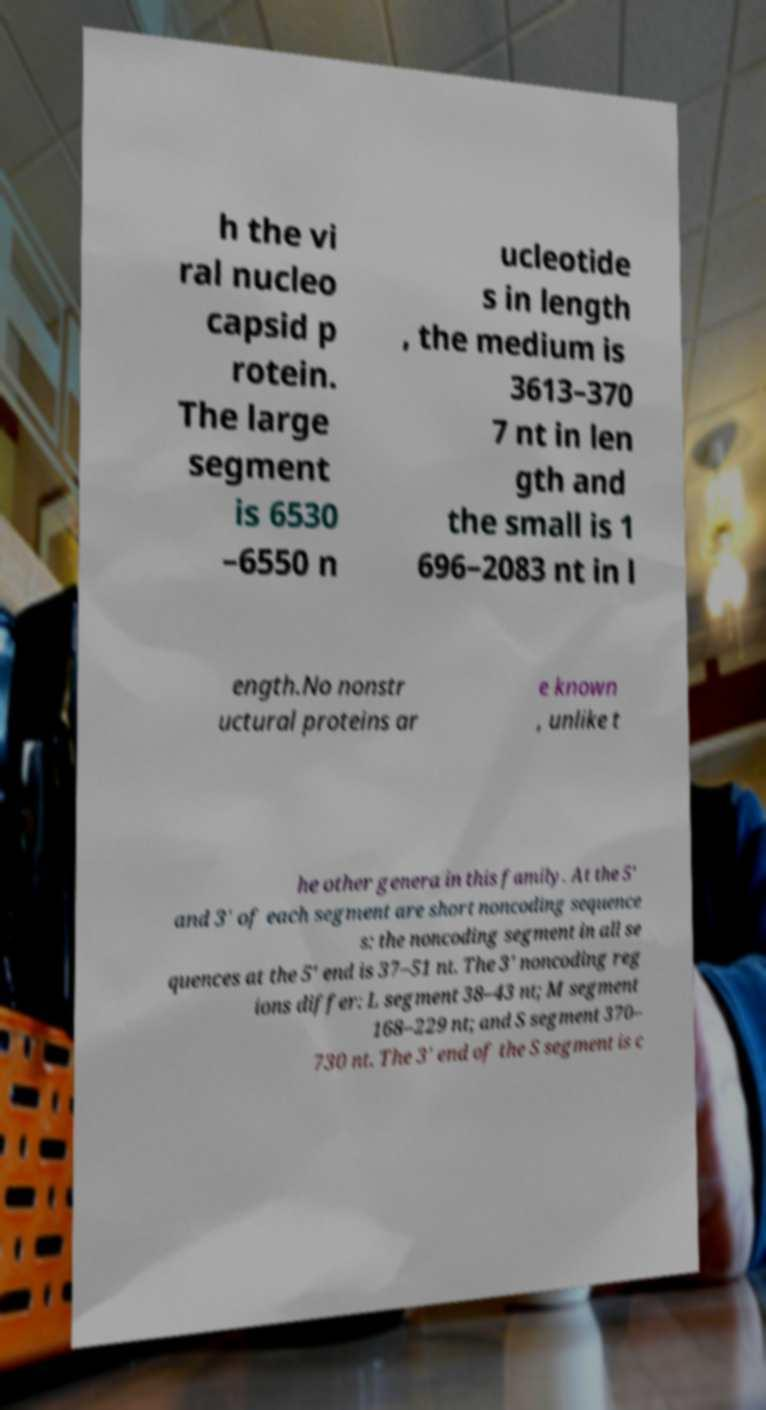Please identify and transcribe the text found in this image. h the vi ral nucleo capsid p rotein. The large segment is 6530 –6550 n ucleotide s in length , the medium is 3613–370 7 nt in len gth and the small is 1 696–2083 nt in l ength.No nonstr uctural proteins ar e known , unlike t he other genera in this family. At the 5' and 3' of each segment are short noncoding sequence s: the noncoding segment in all se quences at the 5' end is 37–51 nt. The 3' noncoding reg ions differ: L segment 38–43 nt; M segment 168–229 nt; and S segment 370– 730 nt. The 3' end of the S segment is c 